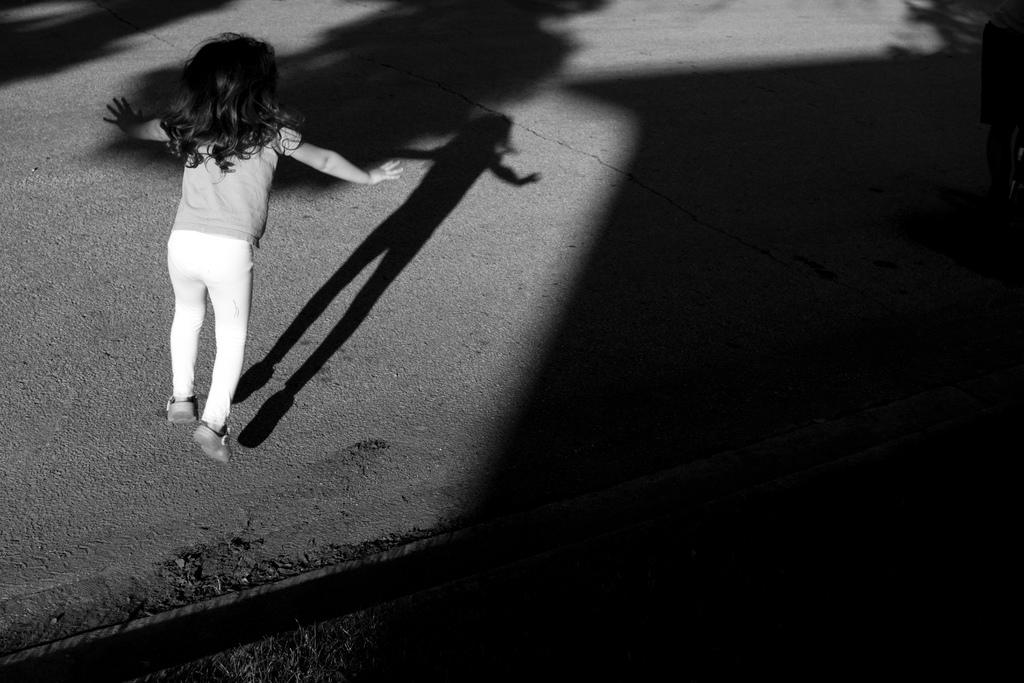Who is the main subject in the image? There is a girl in the image. What is the girl doing in the image? The girl is jumping on the ground. What can be observed about the girl's shadow in the image? There is a shadow of the girl in the image. What type of surface is the girl jumping on? There is grass on the ground in the image. What else can be seen on the ground in the image? There are objects on the ground. What type of boot is the girl wearing in the image? There is no mention of boots in the image; the girl is not wearing any footwear. How does the girl use the comb in the image? There is no comb present in the image. 